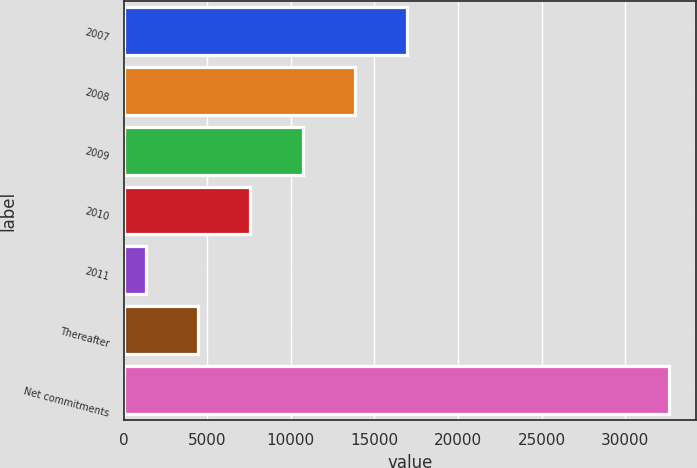Convert chart to OTSL. <chart><loc_0><loc_0><loc_500><loc_500><bar_chart><fcel>2007<fcel>2008<fcel>2009<fcel>2010<fcel>2011<fcel>Thereafter<fcel>Net commitments<nl><fcel>16966.5<fcel>13839.6<fcel>10712.7<fcel>7585.8<fcel>1332<fcel>4458.9<fcel>32601<nl></chart> 